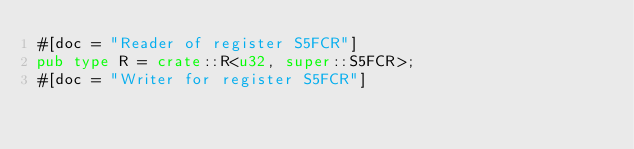<code> <loc_0><loc_0><loc_500><loc_500><_Rust_>#[doc = "Reader of register S5FCR"]
pub type R = crate::R<u32, super::S5FCR>;
#[doc = "Writer for register S5FCR"]</code> 